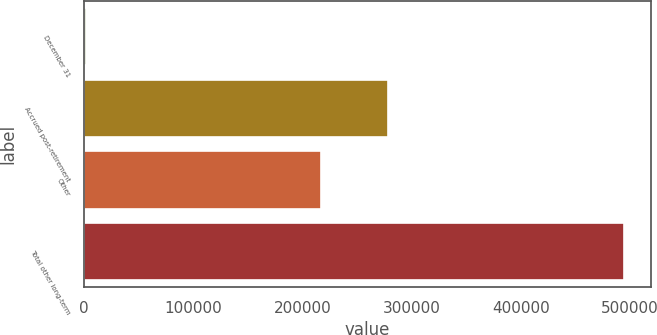Convert chart to OTSL. <chart><loc_0><loc_0><loc_500><loc_500><bar_chart><fcel>December 31<fcel>Accrued post-retirement<fcel>Other<fcel>Total other long-term<nl><fcel>2010<fcel>277963<fcel>216498<fcel>494461<nl></chart> 